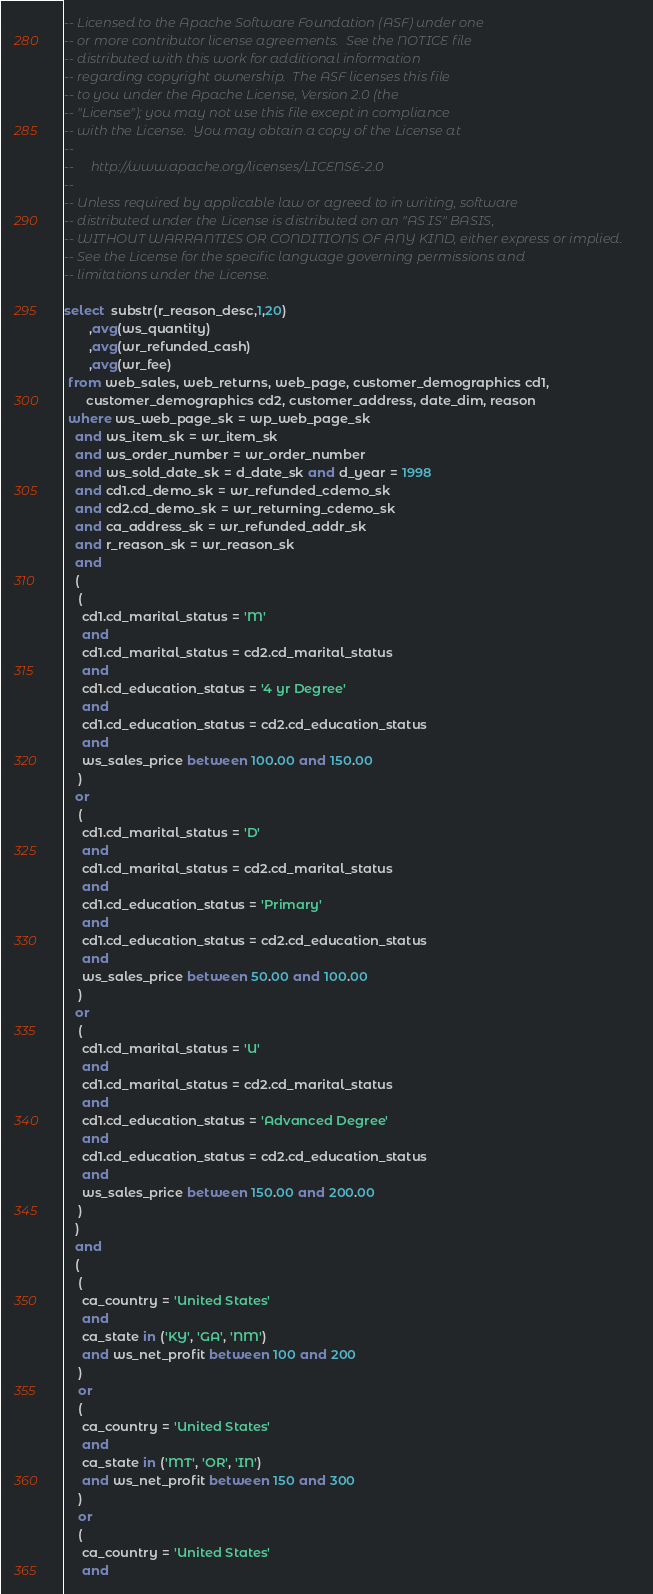<code> <loc_0><loc_0><loc_500><loc_500><_SQL_>-- Licensed to the Apache Software Foundation (ASF) under one
-- or more contributor license agreements.  See the NOTICE file
-- distributed with this work for additional information
-- regarding copyright ownership.  The ASF licenses this file
-- to you under the Apache License, Version 2.0 (the
-- "License"); you may not use this file except in compliance
-- with the License.  You may obtain a copy of the License at
--
--     http://www.apache.org/licenses/LICENSE-2.0
--
-- Unless required by applicable law or agreed to in writing, software
-- distributed under the License is distributed on an "AS IS" BASIS,
-- WITHOUT WARRANTIES OR CONDITIONS OF ANY KIND, either express or implied.
-- See the License for the specific language governing permissions and
-- limitations under the License.

select  substr(r_reason_desc,1,20)
       ,avg(ws_quantity)
       ,avg(wr_refunded_cash)
       ,avg(wr_fee)
 from web_sales, web_returns, web_page, customer_demographics cd1,
      customer_demographics cd2, customer_address, date_dim, reason 
 where ws_web_page_sk = wp_web_page_sk
   and ws_item_sk = wr_item_sk
   and ws_order_number = wr_order_number
   and ws_sold_date_sk = d_date_sk and d_year = 1998
   and cd1.cd_demo_sk = wr_refunded_cdemo_sk 
   and cd2.cd_demo_sk = wr_returning_cdemo_sk
   and ca_address_sk = wr_refunded_addr_sk
   and r_reason_sk = wr_reason_sk
   and
   (
    (
     cd1.cd_marital_status = 'M'
     and
     cd1.cd_marital_status = cd2.cd_marital_status
     and
     cd1.cd_education_status = '4 yr Degree'
     and 
     cd1.cd_education_status = cd2.cd_education_status
     and
     ws_sales_price between 100.00 and 150.00
    )
   or
    (
     cd1.cd_marital_status = 'D'
     and
     cd1.cd_marital_status = cd2.cd_marital_status
     and
     cd1.cd_education_status = 'Primary' 
     and
     cd1.cd_education_status = cd2.cd_education_status
     and
     ws_sales_price between 50.00 and 100.00
    )
   or
    (
     cd1.cd_marital_status = 'U'
     and
     cd1.cd_marital_status = cd2.cd_marital_status
     and
     cd1.cd_education_status = 'Advanced Degree'
     and
     cd1.cd_education_status = cd2.cd_education_status
     and
     ws_sales_price between 150.00 and 200.00
    )
   )
   and
   (
    (
     ca_country = 'United States'
     and
     ca_state in ('KY', 'GA', 'NM')
     and ws_net_profit between 100 and 200  
    )
    or
    (
     ca_country = 'United States'
     and
     ca_state in ('MT', 'OR', 'IN')
     and ws_net_profit between 150 and 300  
    )
    or
    (
     ca_country = 'United States'
     and</code> 